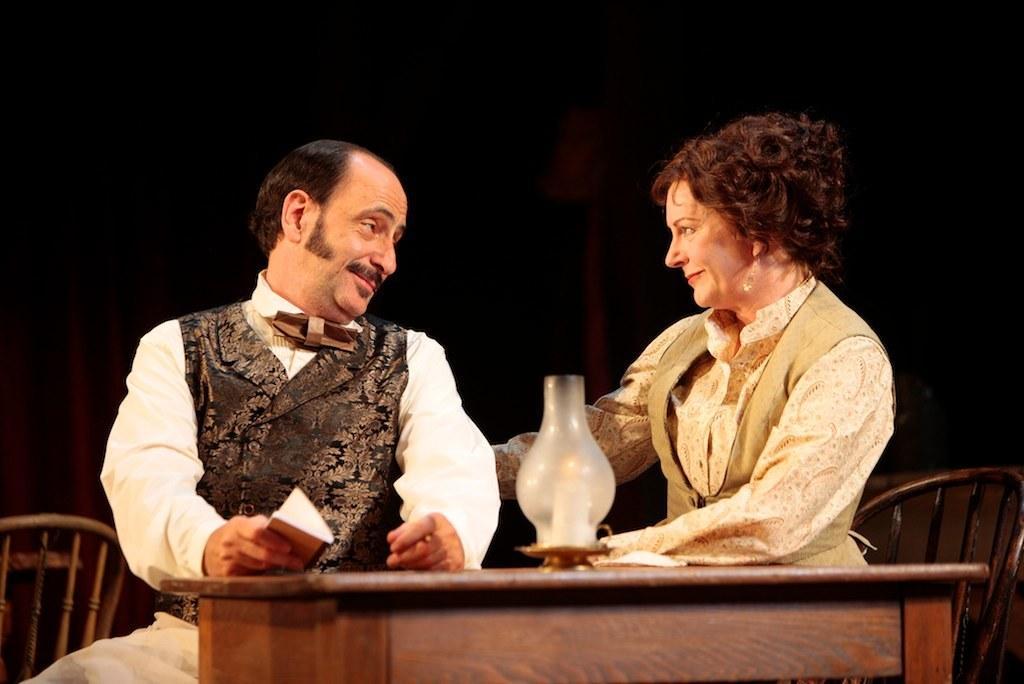Please provide a concise description of this image. In the center we can see two persons were sitting on the chair around the table and they were smiling. On table we can see chimney and he is holding book. In the background there is a wall. 